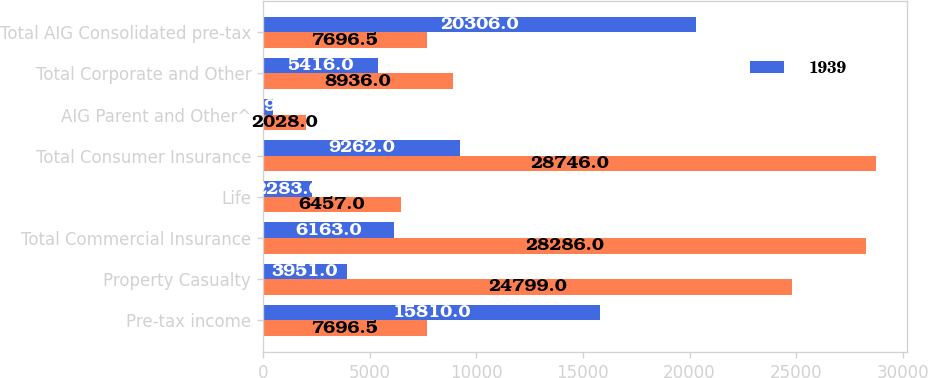Convert chart to OTSL. <chart><loc_0><loc_0><loc_500><loc_500><stacked_bar_chart><ecel><fcel>Pre-tax income<fcel>Property Casualty<fcel>Total Commercial Insurance<fcel>Life<fcel>Total Consumer Insurance<fcel>AIG Parent and Other^<fcel>Total Corporate and Other<fcel>Total AIG Consolidated pre-tax<nl><fcel>nan<fcel>7696.5<fcel>24799<fcel>28286<fcel>6457<fcel>28746<fcel>2028<fcel>8936<fcel>7696.5<nl><fcel>1939<fcel>15810<fcel>3951<fcel>6163<fcel>2283<fcel>9262<fcel>459<fcel>5416<fcel>20306<nl></chart> 